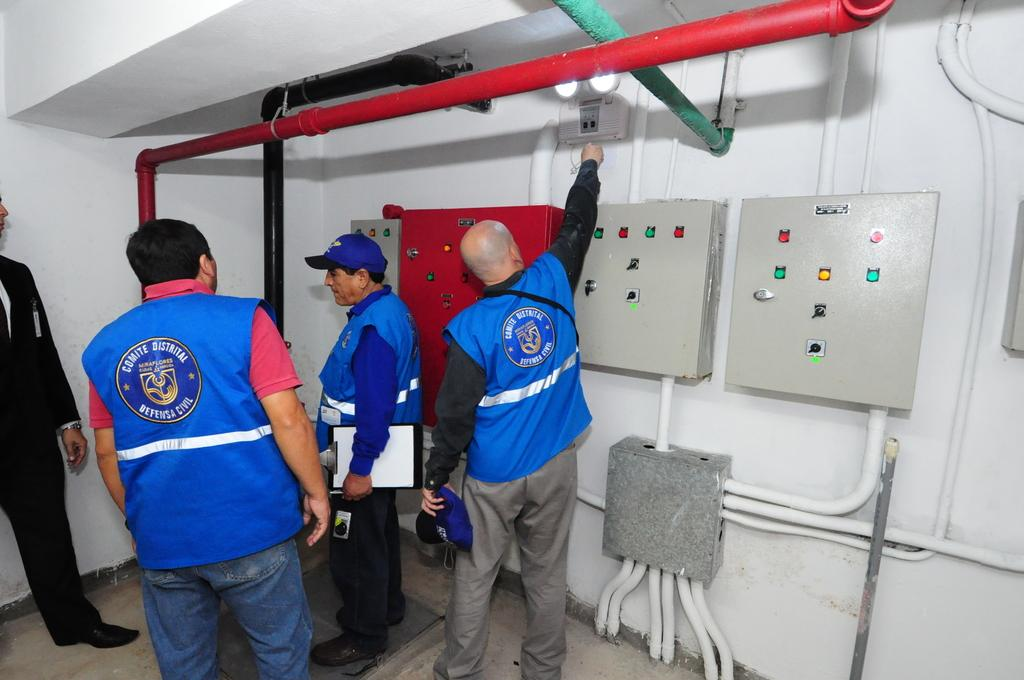How many people are in the image? There are four persons standing in the image. Where are the persons standing? The persons are standing on the floor. What objects can be seen in the image related to construction or infrastructure? There are iron pipes, a junction box, and panel boards attached to the wall in the image. What type of education can be seen being provided in the image? There is no indication of education being provided in the image; it features four persons standing on the floor with construction-related objects. What type of wool is being used to insulate the pipes in the image? There is no wool present in the image; it only shows iron pipes and other construction-related objects. 